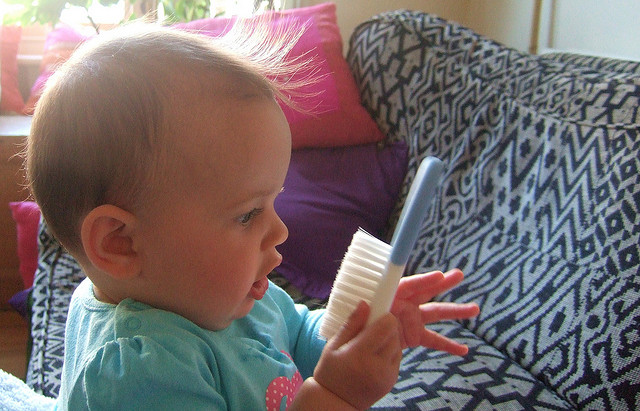What can parents learn from the baby's behavior in this image? From the baby's behavior in this image, parents can learn about their child's curiosity and exploration of new objects. The baby is holding a hairbrush and looking at it in a surprised manner, which shows their interest in the unfamiliar item. This can be an indication that the baby is learning about their surroundings and is in the stage of discovering new objects and their functions. Parents can take this opportunity to guide their child, teach them about safe and appropriate use of various items, and promote their cognitive and motor skill development. It is essential for parents to be observant and responsive to their child's behavior and interests to support their growth and learning experiences. 